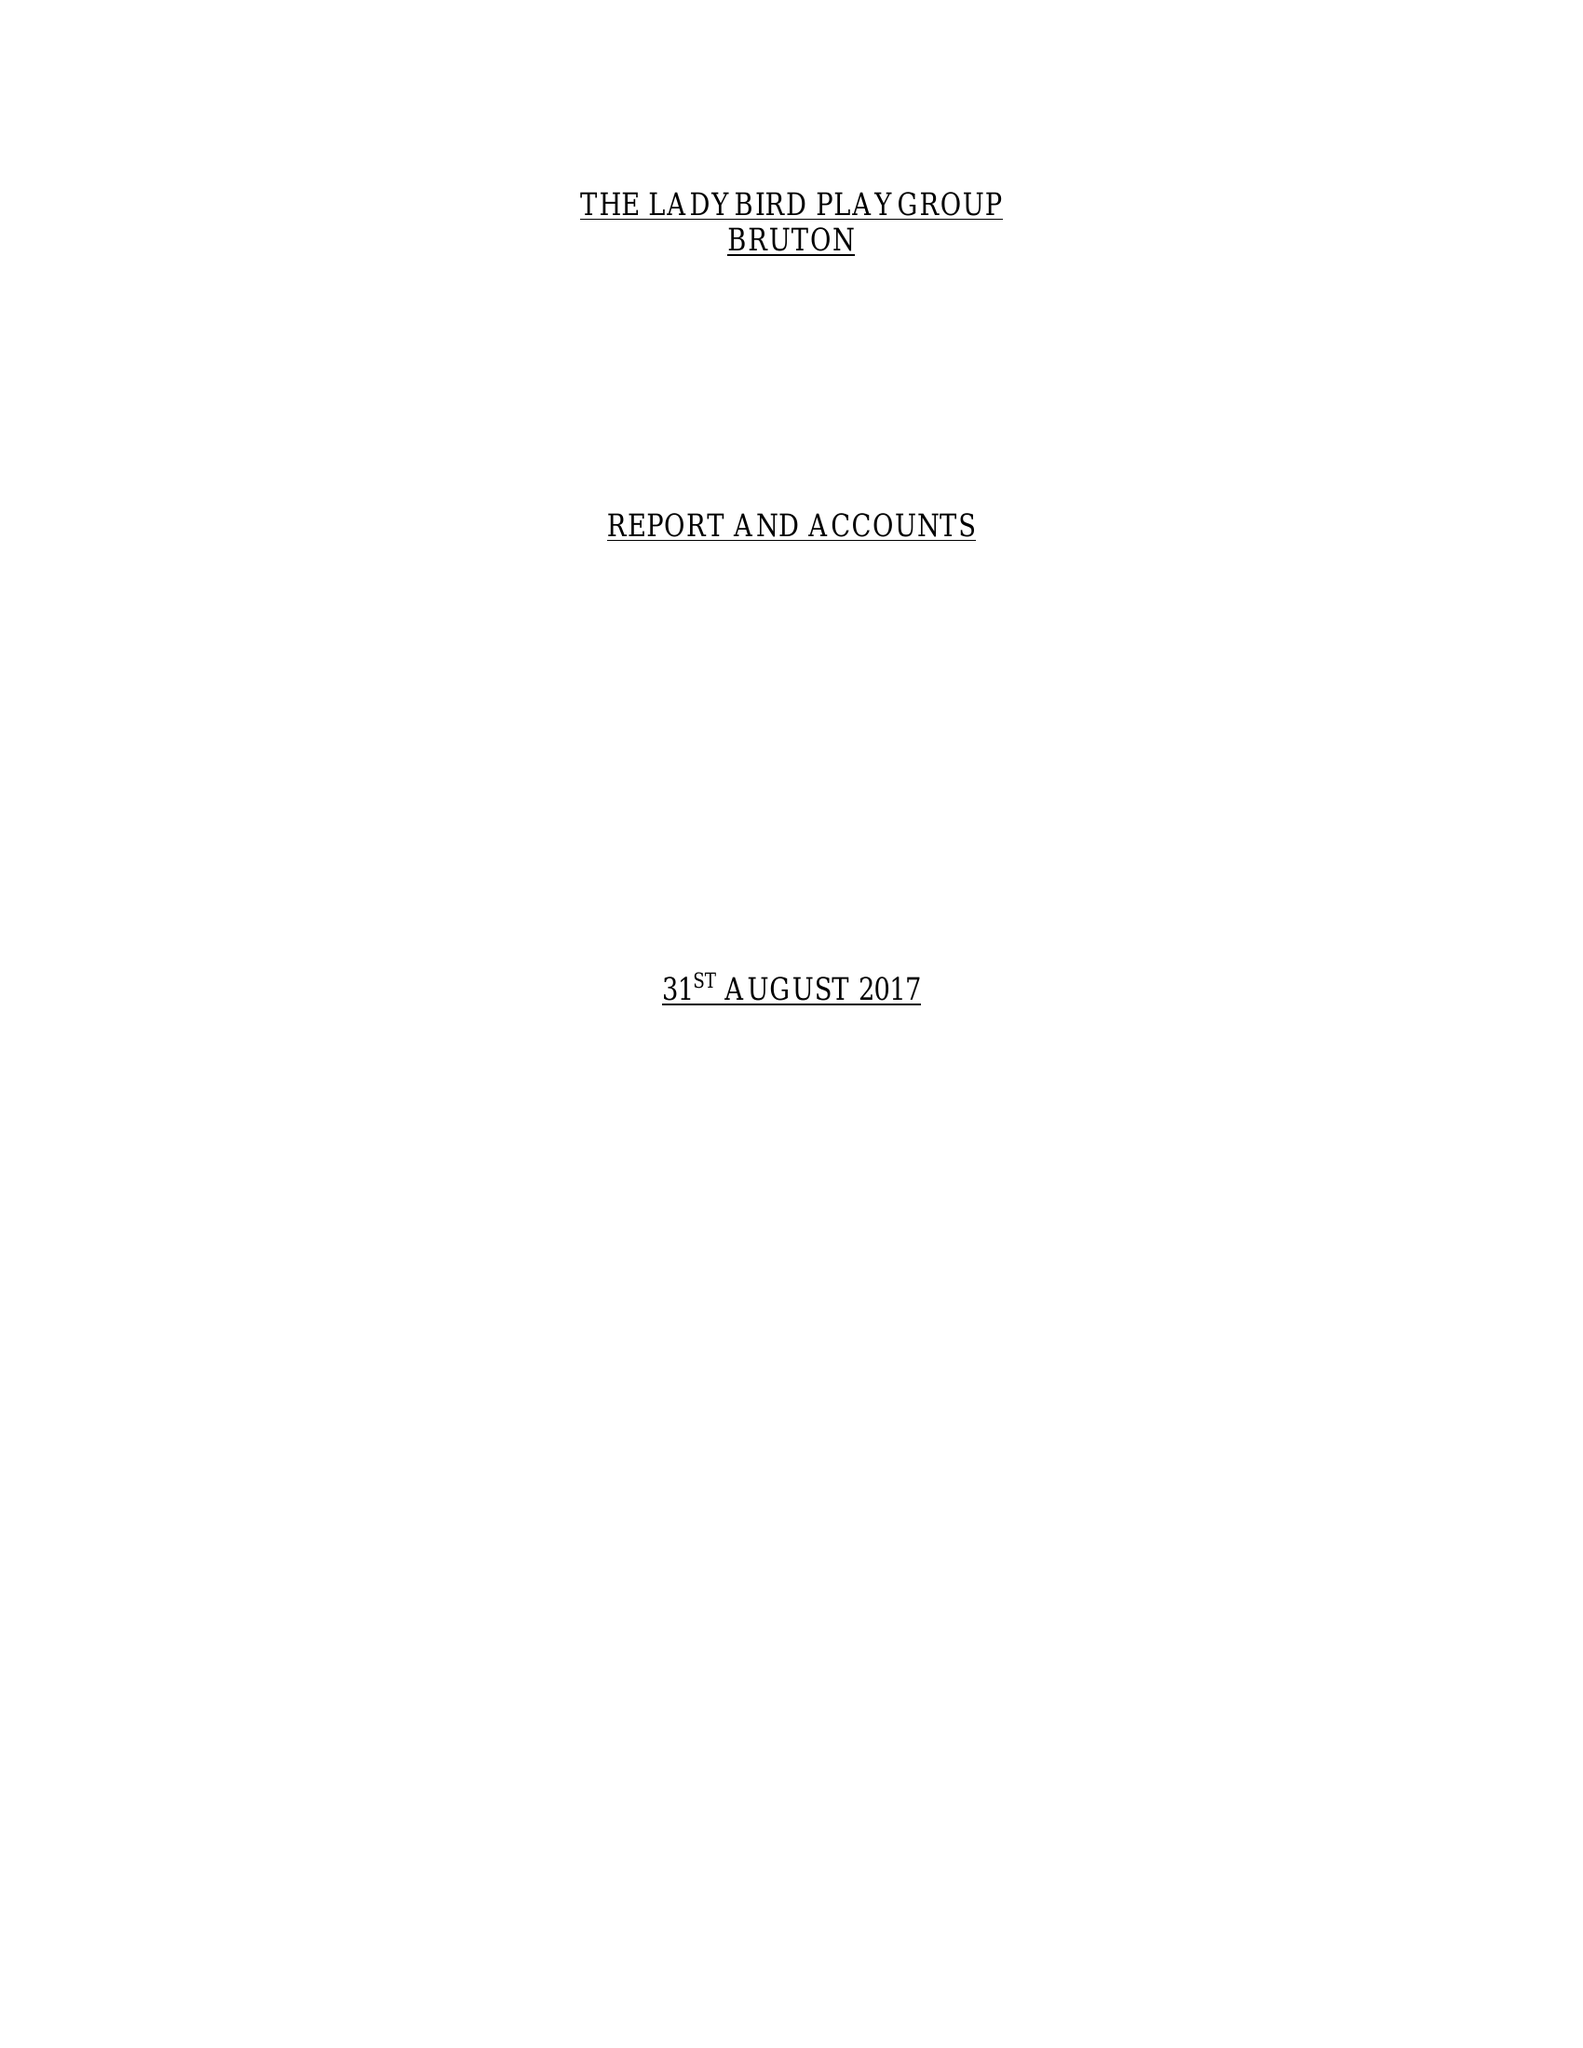What is the value for the charity_name?
Answer the question using a single word or phrase. Ladybird Playgroup 